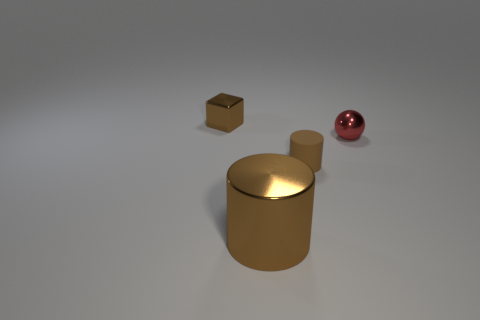Subtract 1 cylinders. How many cylinders are left? 1 Add 1 tiny blue cylinders. How many objects exist? 5 Subtract all spheres. How many objects are left? 3 Add 3 metal balls. How many metal balls are left? 4 Add 3 spheres. How many spheres exist? 4 Subtract 0 brown spheres. How many objects are left? 4 Subtract all blue cylinders. Subtract all gray cubes. How many cylinders are left? 2 Subtract all small brown objects. Subtract all brown metallic things. How many objects are left? 0 